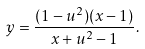<formula> <loc_0><loc_0><loc_500><loc_500>y = \frac { ( 1 - u ^ { 2 } ) ( x - 1 ) } { x + u ^ { 2 } - 1 } .</formula> 